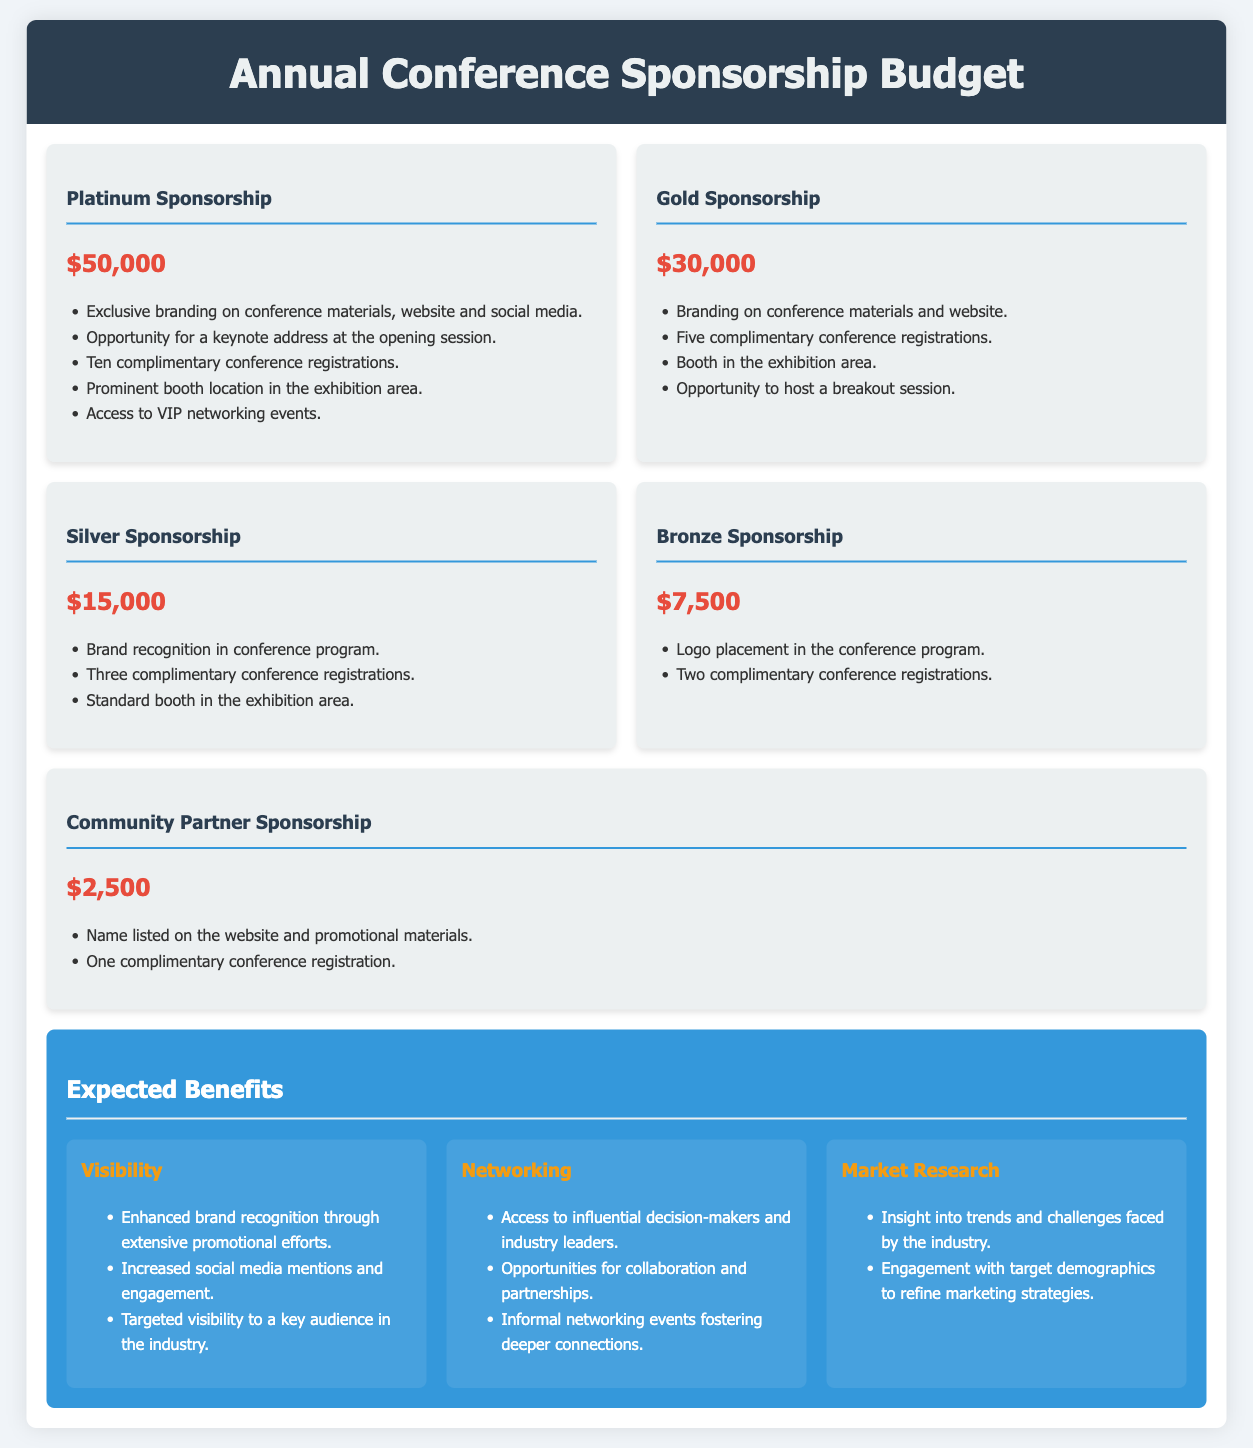What is the cost of Platinum Sponsorship? The cost for Platinum Sponsorship is listed prominently in the sponsorship section of the document.
Answer: $50,000 How many complimentary registrations does Gold Sponsorship provide? The number of complimentary registrations is mentioned under the Gold Sponsorship benefits.
Answer: Five What opportunity is provided for Bronze Sponsors? Opportunities for Bronze Sponsors are outlined under their specific section in the document.
Answer: Logo placement in the conference program What is the minimum amount for sponsorship? The minimum sponsorship level and amount are clearly listed among the different levels.
Answer: $2,500 Which sponsorship level includes a keynote address opportunity? The specific level that mentions the opportunity for a keynote address can be found in the description of the sponsorships.
Answer: Platinum Sponsorship What is one expected benefit related to visibility? The benefits are categorized, and the visibility benefits are outlined.
Answer: Enhanced brand recognition through extensive promotional efforts How many booths are available to Silver Sponsors? The number of booths available to Silver Sponsors is specified in their benefits section.
Answer: Standard booth in the exhibition area What type of event access is offered to Platinum Sponsors? The document specifies the type of events that Platinum Sponsors have access to within their benefits.
Answer: VIP networking events Which sponsorship provides the highest level of visibility? By comparing the visibility benefits across the different levels, the highest can be identified.
Answer: Platinum Sponsorship 